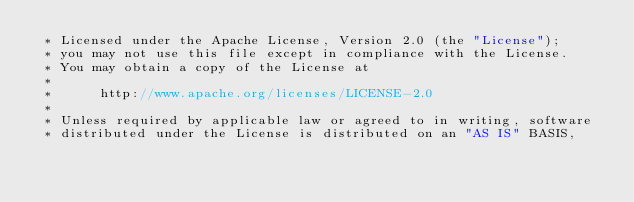<code> <loc_0><loc_0><loc_500><loc_500><_Java_> * Licensed under the Apache License, Version 2.0 (the "License");
 * you may not use this file except in compliance with the License.
 * You may obtain a copy of the License at
 *
 *      http://www.apache.org/licenses/LICENSE-2.0
 *
 * Unless required by applicable law or agreed to in writing, software
 * distributed under the License is distributed on an "AS IS" BASIS,</code> 